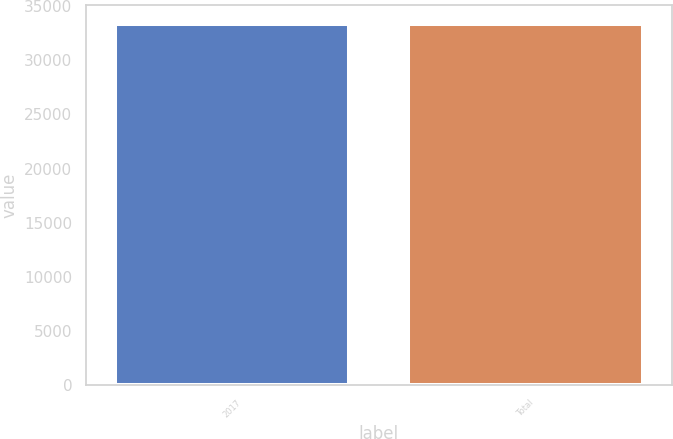Convert chart. <chart><loc_0><loc_0><loc_500><loc_500><bar_chart><fcel>2017<fcel>Total<nl><fcel>33403<fcel>33403.1<nl></chart> 